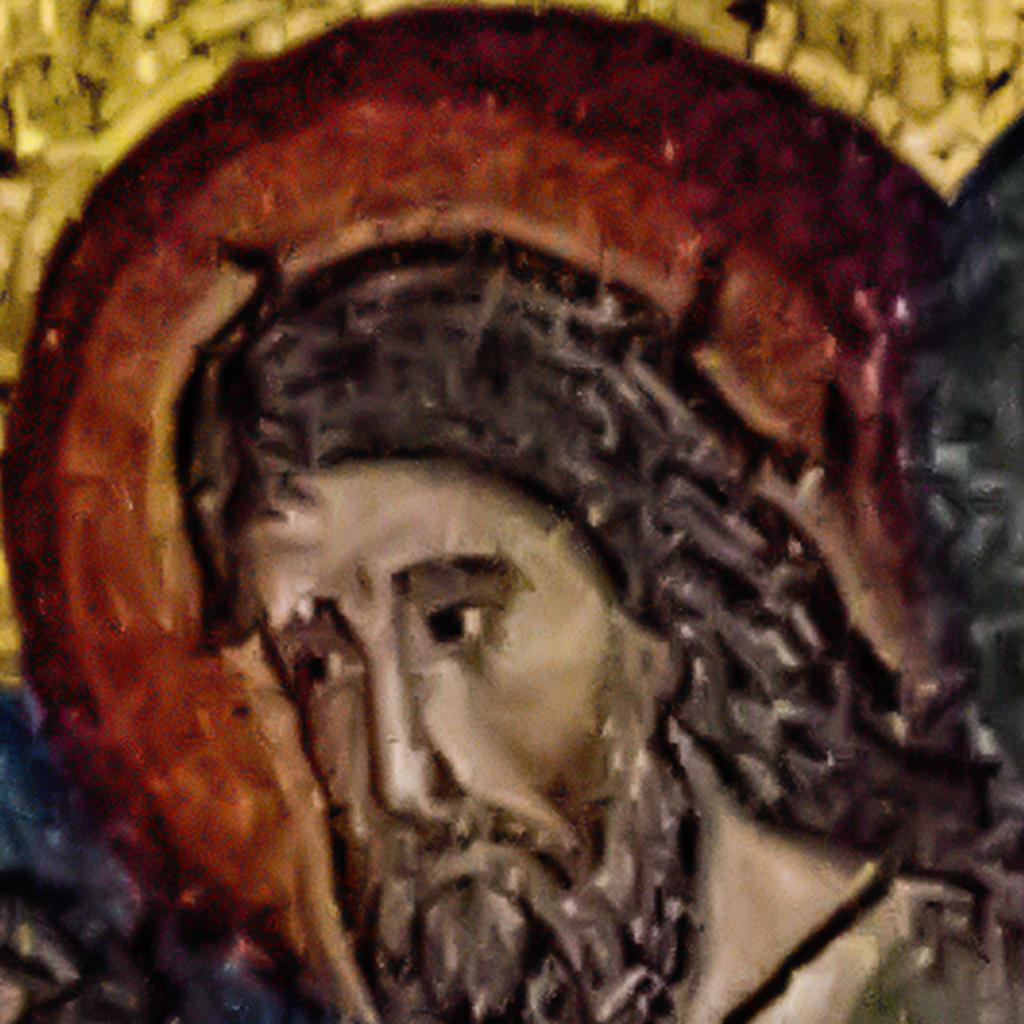What is the main subject of the painting in the image? There is a painting of a person in the image. How many cacti are present in the painting? A: There is no mention of cacti in the image or the painting; the painting features a person. 